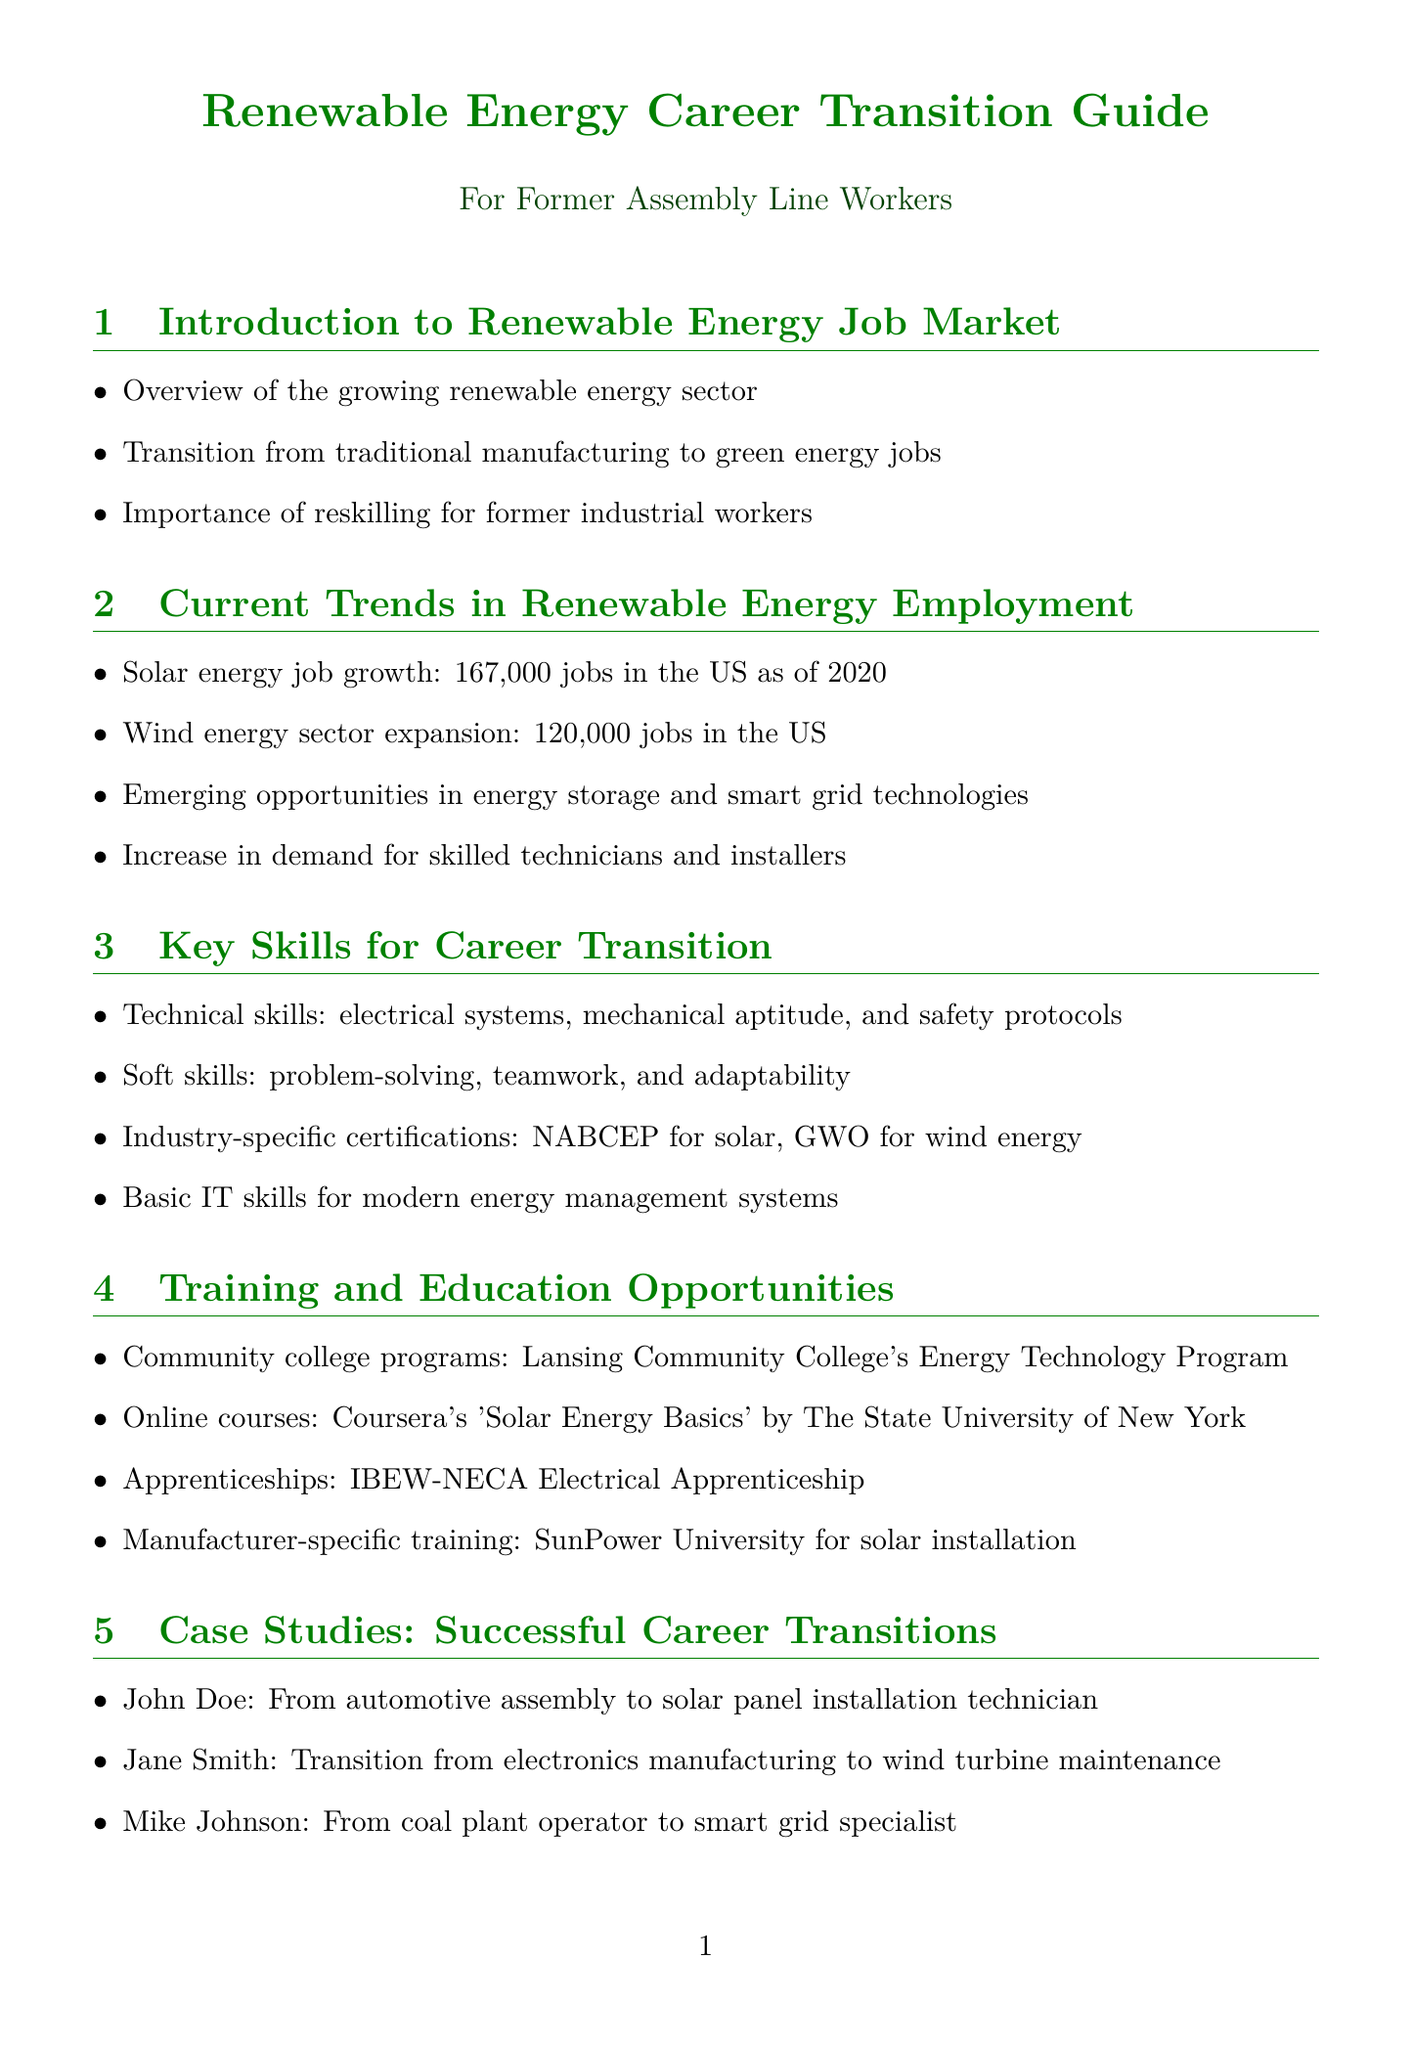What is the job growth in solar energy as of 2020? The document states that there are 167,000 jobs in solar energy in the US as of 2020.
Answer: 167,000 jobs What certification is for solar energy? The document mentions the NABCEP certification for solar energy.
Answer: NABCEP What are two key soft skills mentioned for career transition? The document lists problem-solving and teamwork as important soft skills.
Answer: Problem-solving, teamwork Which region is noted for growth in wind energy jobs? The document highlights the Midwest, particularly Iowa and Illinois, for wind energy job growth.
Answer: Midwest, Iowa, Illinois What is the salary range for an entry-level solar installer? The document specifies that an entry-level solar installer earns between $35,000 and $45,000 per year.
Answer: $35,000 - $45,000 What emerging technology is related to electric vehicle charging? The document lists electric vehicle charging infrastructure development as an emerging technology.
Answer: Electric vehicle charging infrastructure Which community college program is mentioned in the training opportunities? The document mentions Lansing Community College's Energy Technology Program.
Answer: Lansing Community College's Energy Technology Program What is the job title with the highest salary expectation? The document indicates that a renewable energy project manager has the highest salary expectation.
Answer: Renewable energy project manager 